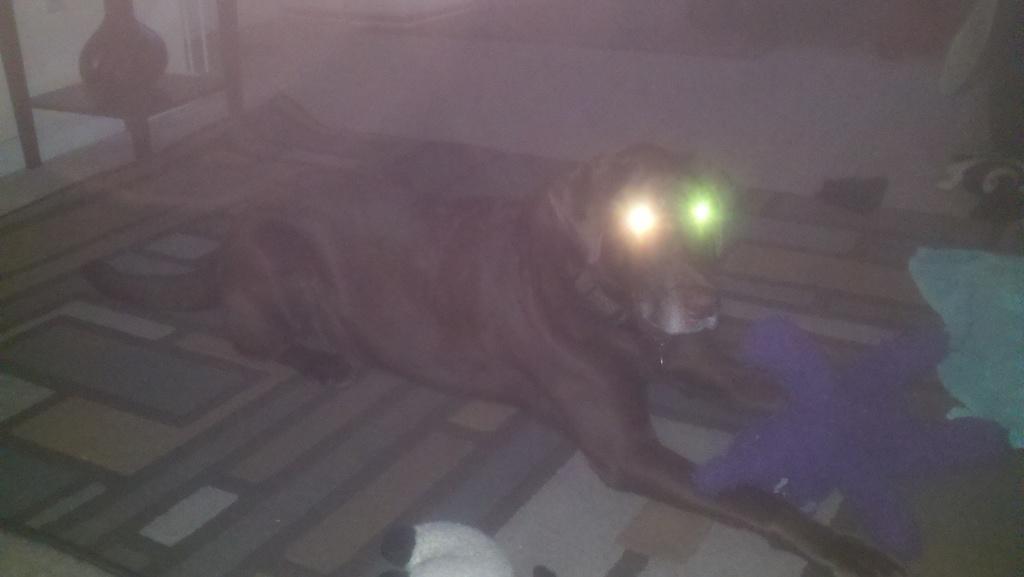How would you summarize this image in a sentence or two? In this image, I can see a black color dog is sitting on the floor mat. Dog's eyes are shining like lights. 